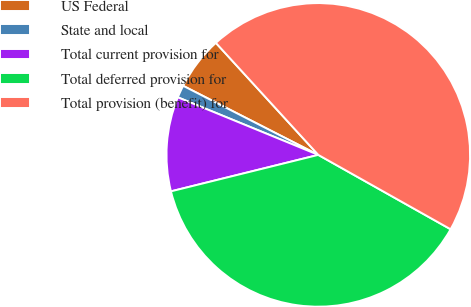Convert chart to OTSL. <chart><loc_0><loc_0><loc_500><loc_500><pie_chart><fcel>US Federal<fcel>State and local<fcel>Total current provision for<fcel>Total deferred provision for<fcel>Total provision (benefit) for<nl><fcel>5.69%<fcel>1.33%<fcel>10.05%<fcel>37.98%<fcel>44.93%<nl></chart> 